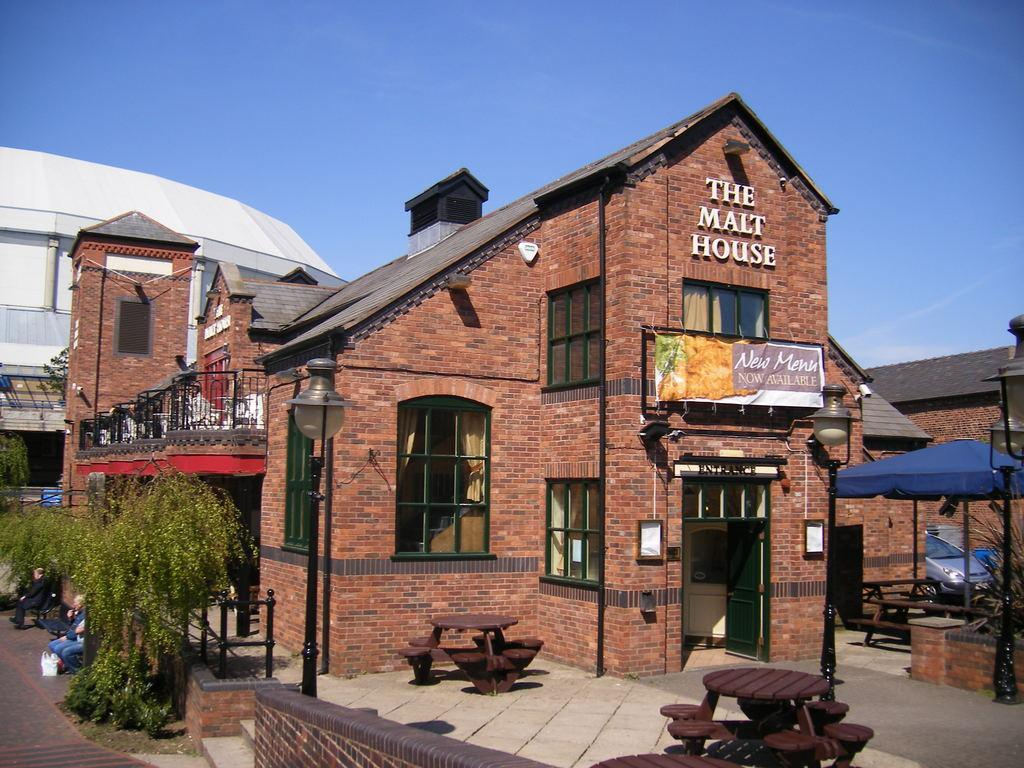What type of structure is visible in the image? There is a building in the image. What kind of building might it be? The building appears to be a hotel. Are there any outdoor seating areas in front of the building? Yes, there are tables in front of the building. What can be seen on the left side of the image? There are plants on the left side of the image. What is visible above the building? The sky is visible above the building. Can you tell me how many deer are visible in the image? There are no deer visible in the image. 